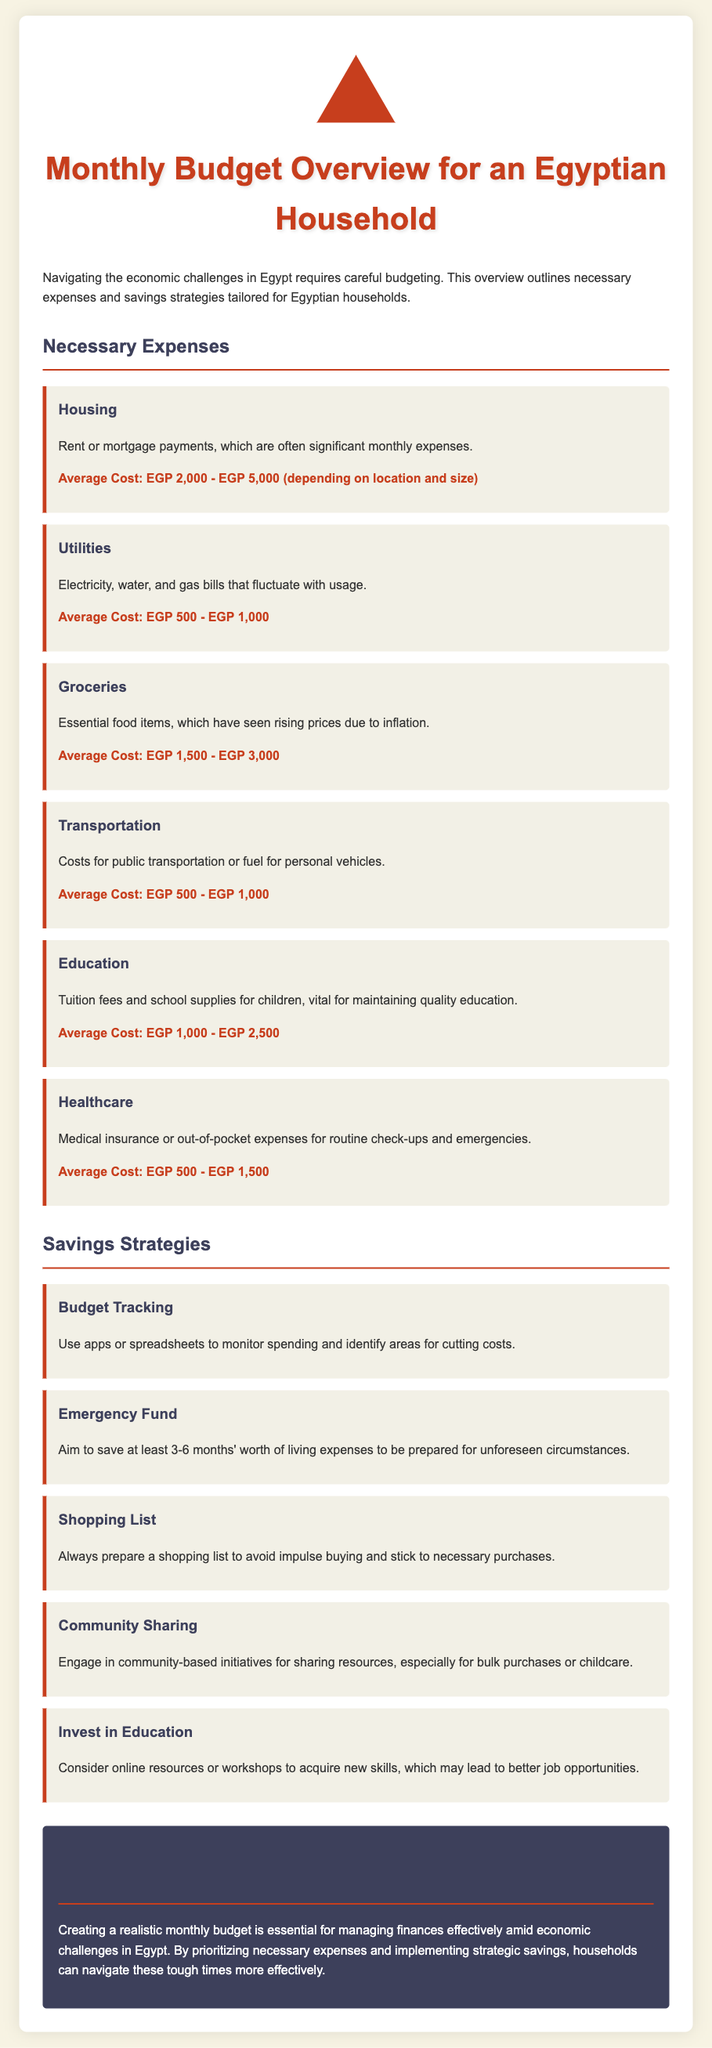What is the average cost of housing? The average cost of housing is mentioned as EGP 2,000 - EGP 5,000 depending on location and size.
Answer: EGP 2,000 - EGP 5,000 What is a necessary expense for education? Necessary expenses for education include tuition fees and school supplies for children.
Answer: Tuition fees and school supplies How much should an emergency fund cover? The document states that one should aim to save at least 3-6 months' worth of living expenses for an emergency fund.
Answer: 3-6 months' worth of living expenses What are the average utility costs? The average cost of utilities is stated within a range in the document.
Answer: EGP 500 - EGP 1,000 What savings strategy involves monitoring spending? The savings strategy that involves monitoring spending is mentioned in the section on savings strategies.
Answer: Budget Tracking What is a critical component of grocery expenses? The document highlights that essential food items are critical components of grocery expenses.
Answer: Essential food items What is the average cost of healthcare? The document provides a specific range for average healthcare expenses.
Answer: EGP 500 - EGP 1,500 Which strategy suggests preparing a list before shopping? The strategy that suggests preparing a list before shopping is included among the savings strategies.
Answer: Shopping List What is one way to engage the community for savings? The document mentions community-sharing initiatives as a way to engage and save.
Answer: Community Sharing 